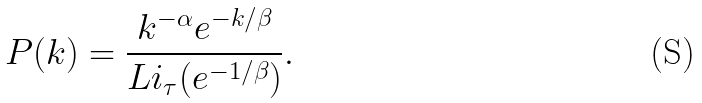Convert formula to latex. <formula><loc_0><loc_0><loc_500><loc_500>P ( k ) = \frac { k ^ { - \alpha } e ^ { - k / \beta } } { L i _ { \tau } ( e ^ { - 1 / \beta } ) } .</formula> 